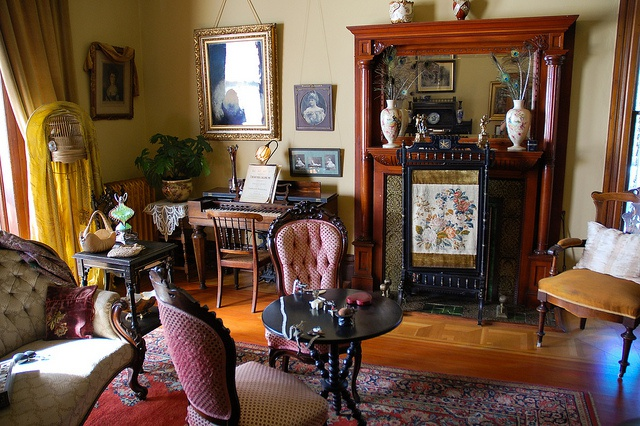Describe the objects in this image and their specific colors. I can see couch in black, maroon, and white tones, chair in black, maroon, and brown tones, chair in black, lightgray, maroon, and brown tones, dining table in black, gray, maroon, and navy tones, and chair in black, maroon, brown, and lavender tones in this image. 